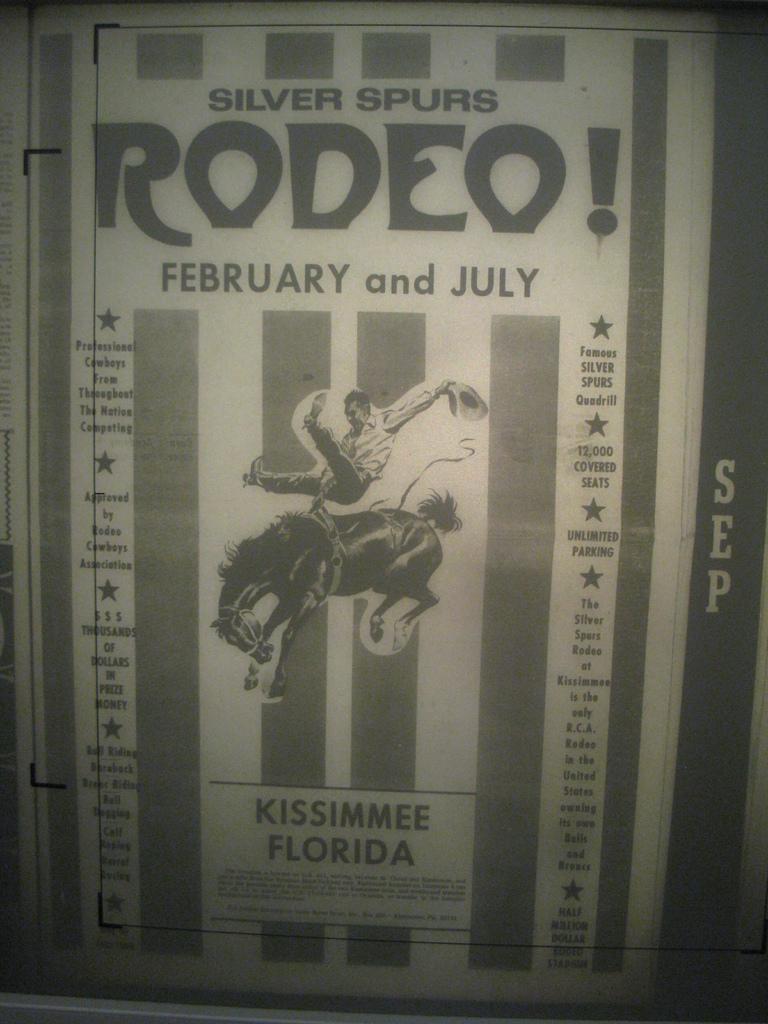What event is this advertising?
Make the answer very short. Rodeo. What month is on the ad?
Keep it short and to the point. February and july. 